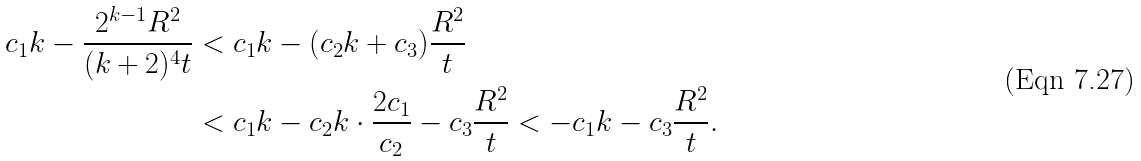<formula> <loc_0><loc_0><loc_500><loc_500>c _ { 1 } k - \frac { 2 ^ { k - 1 } R ^ { 2 } } { ( k + 2 ) ^ { 4 } t } & < c _ { 1 } k - ( c _ { 2 } k + c _ { 3 } ) \frac { R ^ { 2 } } { t } \\ & < c _ { 1 } k - c _ { 2 } k \cdot \frac { 2 c _ { 1 } } { c _ { 2 } } - c _ { 3 } \frac { R ^ { 2 } } { t } < - c _ { 1 } k - c _ { 3 } \frac { R ^ { 2 } } { t } .</formula> 